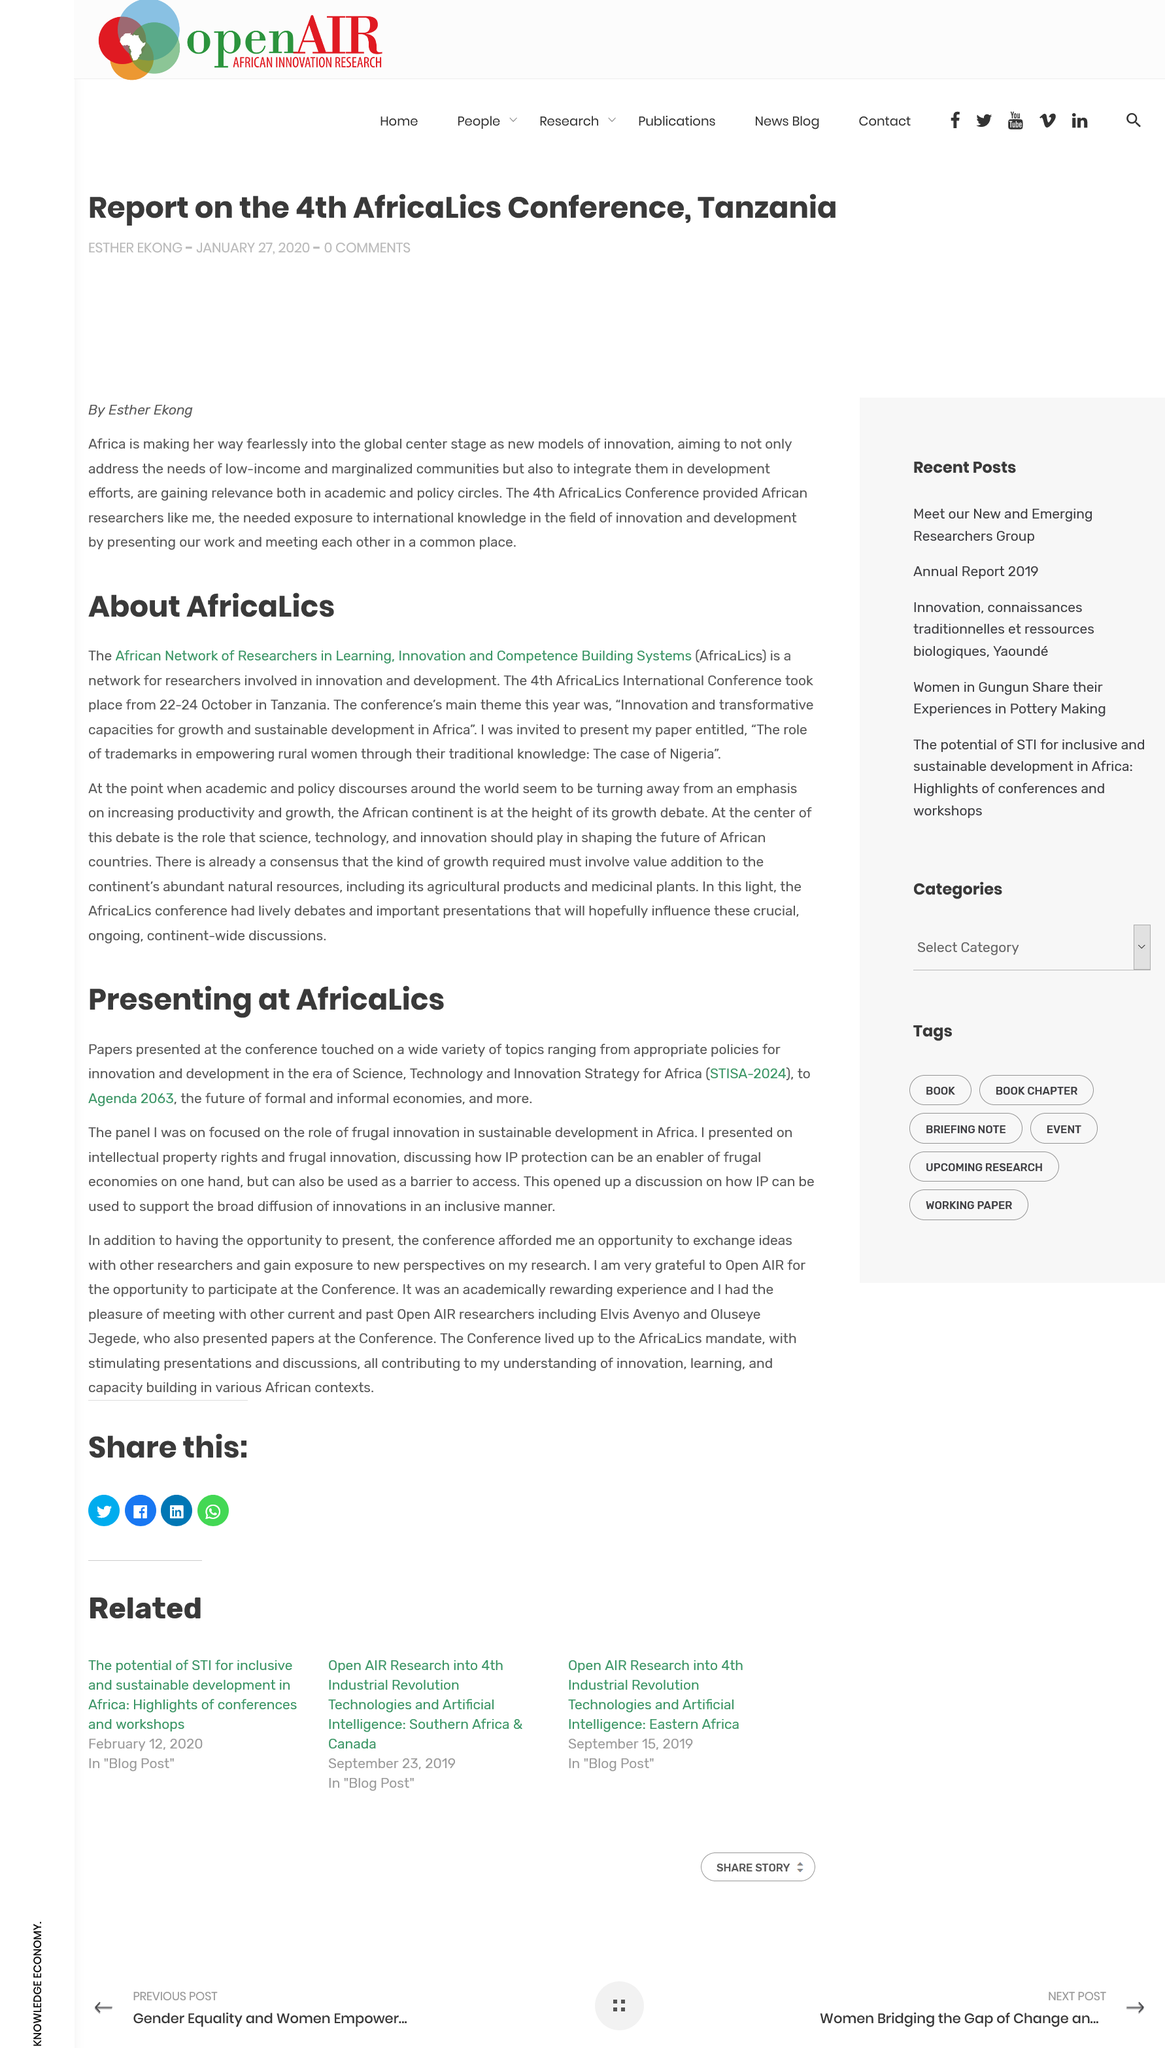Point out several critical features in this image. Yes, intellectual property can be used to support the broad diffusion of innovations, provided it is used in an inclusive and equitable manner. IP protection can be multifaceted and serve as both an enabler and a barrier to access. The 4th AfricaLics International Conference took place on 22-24 October in Tanzania. Agenda 2063 is a plan for the future of both formal and informal economies, aimed at achieving sustainable development and a better life for all. AfricaLics is an acronym that stands for the African Network of Researchers in Learning, Innovation, and Competence Building Systems. 